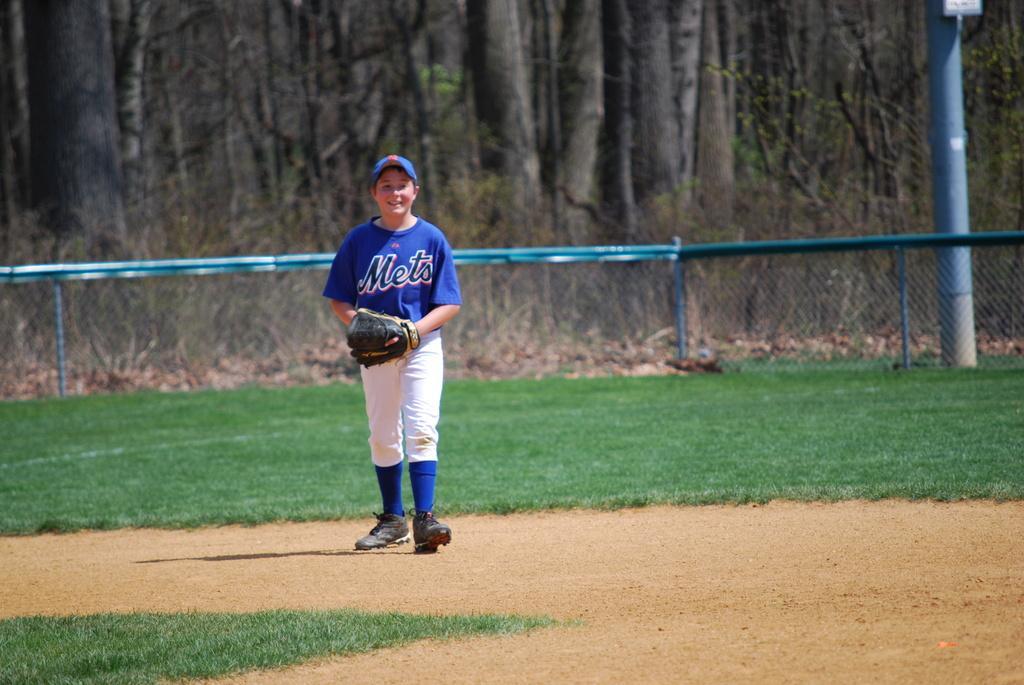Could you give a brief overview of what you see in this image? In the foreground of this image, there is a person wearing glove and standing on the ground. We can also see the grassland. In the background, there is fencing and the trees. On the right, there is a pole. 